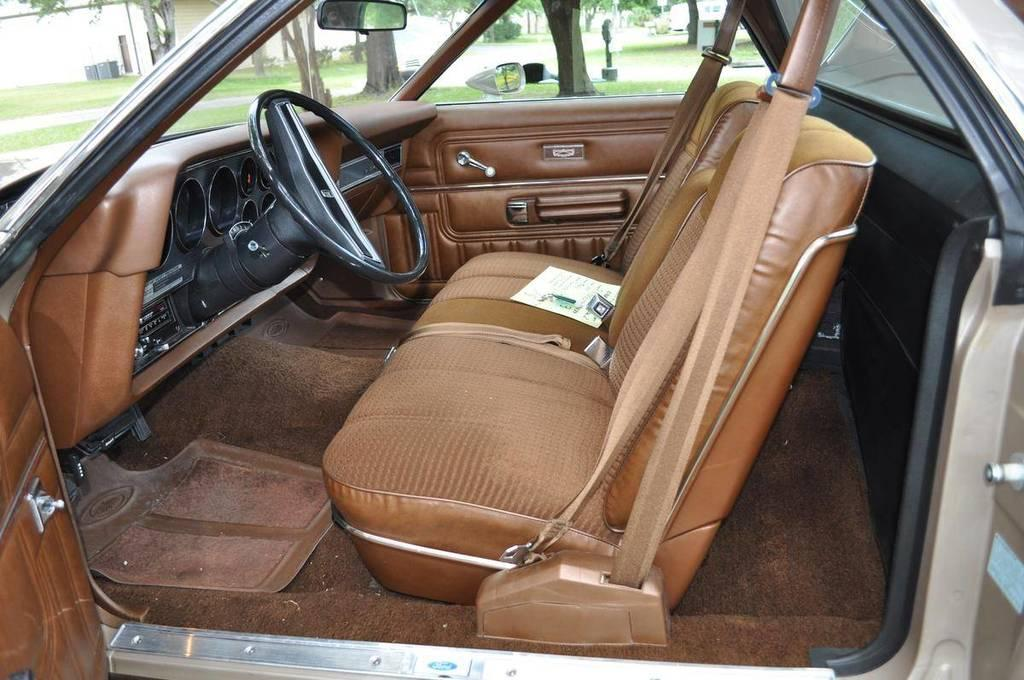What type of view does the image provide? The image provides an inside view of a car. What is one of the main components of a car that is visible in the image? The steering wheel is visible in the image. What part of the car is designed for passengers to sit on? The car seat is visible in the image. What part of the car allows the driver to see behind them? The car mirror is visible in the image. What part of the car allows for ventilation and visibility? The car window is visible in the image. Where is the jail located in the image? There is no jail present in the image. What type of animal can be seen grazing in the car? There are no animals present in the image. 